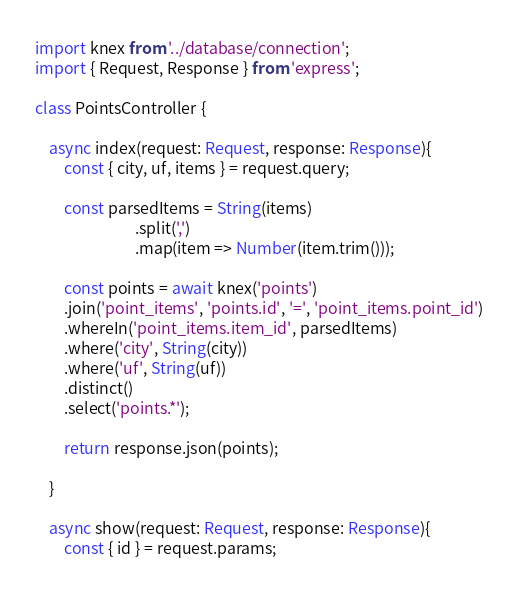<code> <loc_0><loc_0><loc_500><loc_500><_TypeScript_>import knex from '../database/connection';
import { Request, Response } from 'express';

class PointsController {

    async index(request: Request, response: Response){
        const { city, uf, items } = request.query;
        
        const parsedItems = String(items)
                            .split(',')
                            .map(item => Number(item.trim()));

        const points = await knex('points')
        .join('point_items', 'points.id', '=', 'point_items.point_id')
        .whereIn('point_items.item_id', parsedItems)
        .where('city', String(city))
        .where('uf', String(uf))
        .distinct()
        .select('points.*');

        return response.json(points);

    }

    async show(request: Request, response: Response){
        const { id } = request.params;</code> 